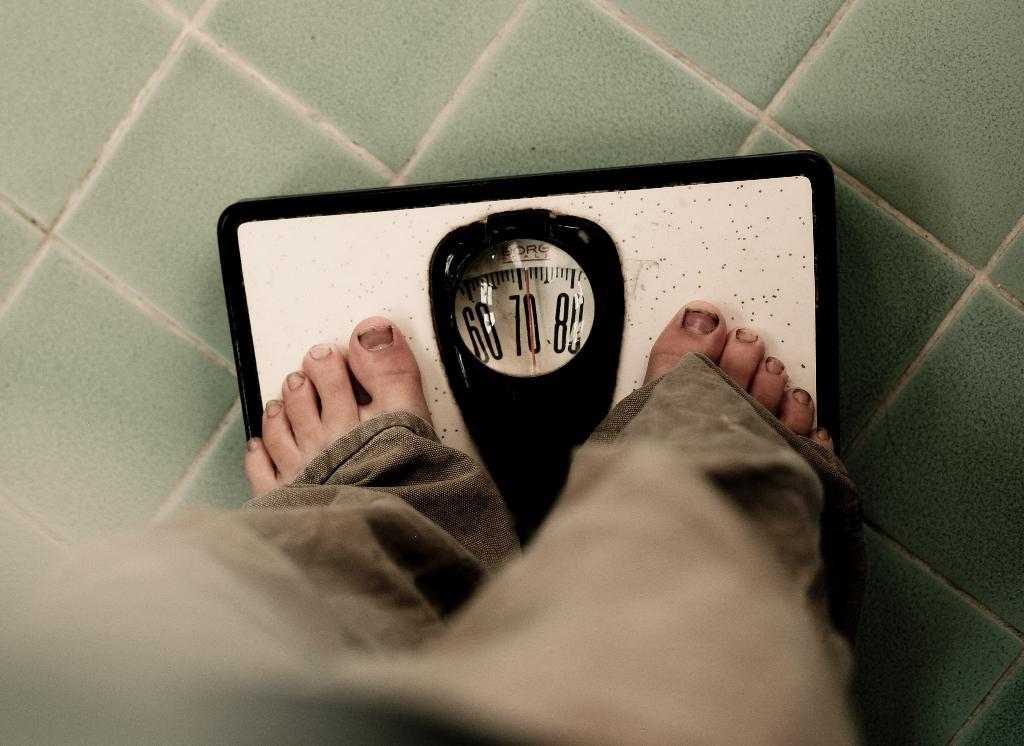What is the main subject of the image? There is a person in the image. What is the person doing in the image? The person is standing on a weight machine. What color is the ground in the image? The ground is in green color. What type of stone can be seen in the image? There is no stone present in the image. Is there a liquid visible in the image? No, there is no liquid visible in the image. 